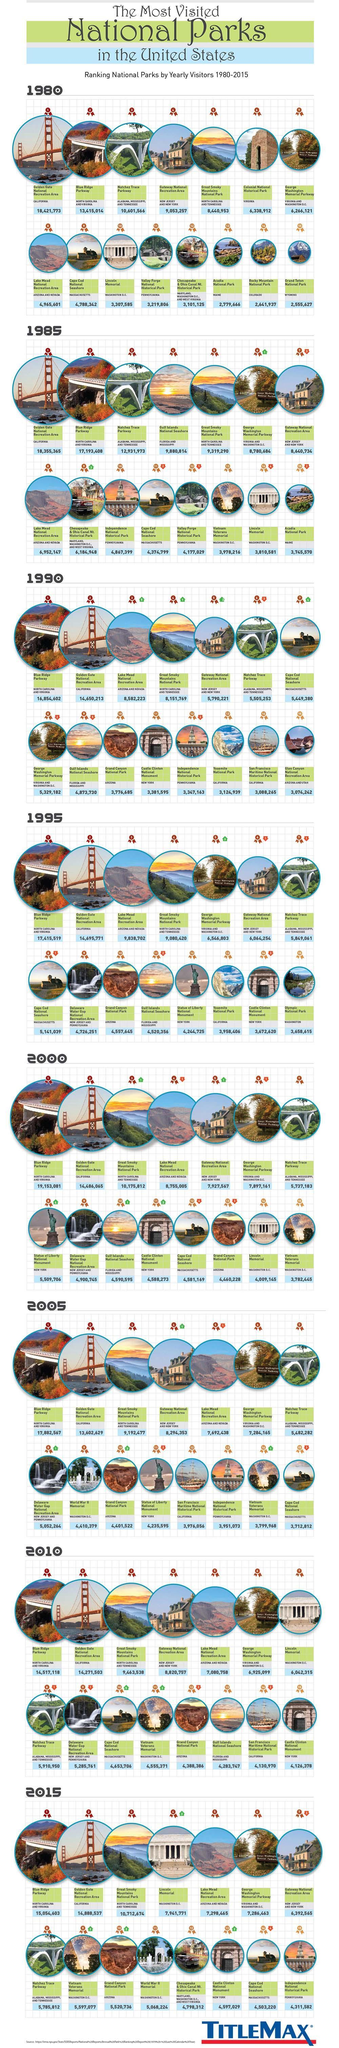Which national park moved up three places in ranking in 2000?
Answer the question with a short phrase. Castle Clinton National Monument How many positions did the ranking for Lake Mead National recreation area increase in 1990? 5 Which year recorded the highest number of visitors at Golden gate national park 1980, 1990, or 1985 ? 1990 What was the ranking of Yosemite National park in 1995 ? 13 Which year did Grand Canyon National park receive the highest ranking  2000, 2005, or 2010 ? 2005 How many national parks are listed ? 15 How many years have been included for the ranking data? 8 What was the total number of visitors to Cape Cod National Seashore , Independence National Historical Park, or Castle Clinton National Monument in 2015? 13,411,831 What was the increase in number visitors in Gateway National recreation area from 1990 to 1995? 2,74,033 What was the fall in the number of visitors from 1980 to 1985? 66,408 